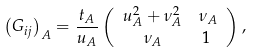<formula> <loc_0><loc_0><loc_500><loc_500>\left ( G _ { i j } \right ) _ { A } & = \frac { t _ { A } } { u _ { A } } \left ( \begin{array} { c c } u _ { A } ^ { 2 } + \nu _ { A } ^ { 2 } & \nu _ { A } \\ \nu _ { A } & 1 \ \end{array} \right ) ,</formula> 